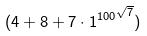<formula> <loc_0><loc_0><loc_500><loc_500>( 4 + 8 + 7 \cdot { 1 ^ { 1 0 0 } } ^ { \sqrt { 7 } } )</formula> 